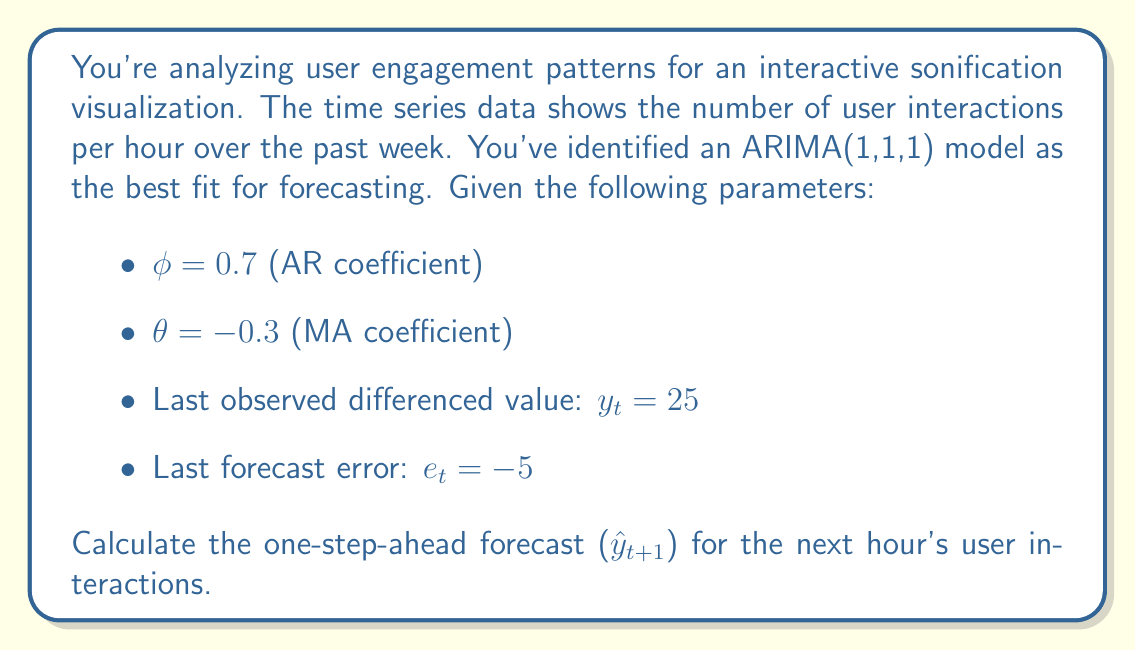Teach me how to tackle this problem. To solve this problem, we'll use the ARIMA(1,1,1) model equation and follow these steps:

1) The general form of an ARIMA(1,1,1) model is:

   $$(1-B)(1-\phi B)Y_t = (1-\theta B)e_t$$

   where $B$ is the backshift operator.

2) Expanding this equation gives us:

   $$Y_t - Y_{t-1} = \phi(Y_{t-1} - Y_{t-2}) + e_t - \theta e_{t-1}$$

3) Let $y_t = Y_t - Y_{t-1}$ be the differenced series. Then our forecast equation becomes:

   $$\hat{y}_{t+1} = \phi y_t - \theta e_t$$

4) We're given the following values:
   - $\phi = 0.7$
   - $\theta = -0.3$
   - $y_t = 25$
   - $e_t = -5$

5) Plugging these values into our equation:

   $$\hat{y}_{t+1} = 0.7(25) - (-0.3)(-5)$$

6) Simplifying:

   $$\hat{y}_{t+1} = 17.5 - 1.5 = 16$$

7) Remember that this is the forecast for the differenced series. To get the actual forecast for $Y_{t+1}$, we need to add this to the last observed value $Y_t$:

   $$\hat{Y}_{t+1} = Y_t + \hat{y}_{t+1}$$

   However, we're not given $Y_t$, so we can only report the differenced forecast.
Answer: The one-step-ahead forecast for the differenced series is $\hat{y}_{t+1} = 16$ user interactions per hour. 